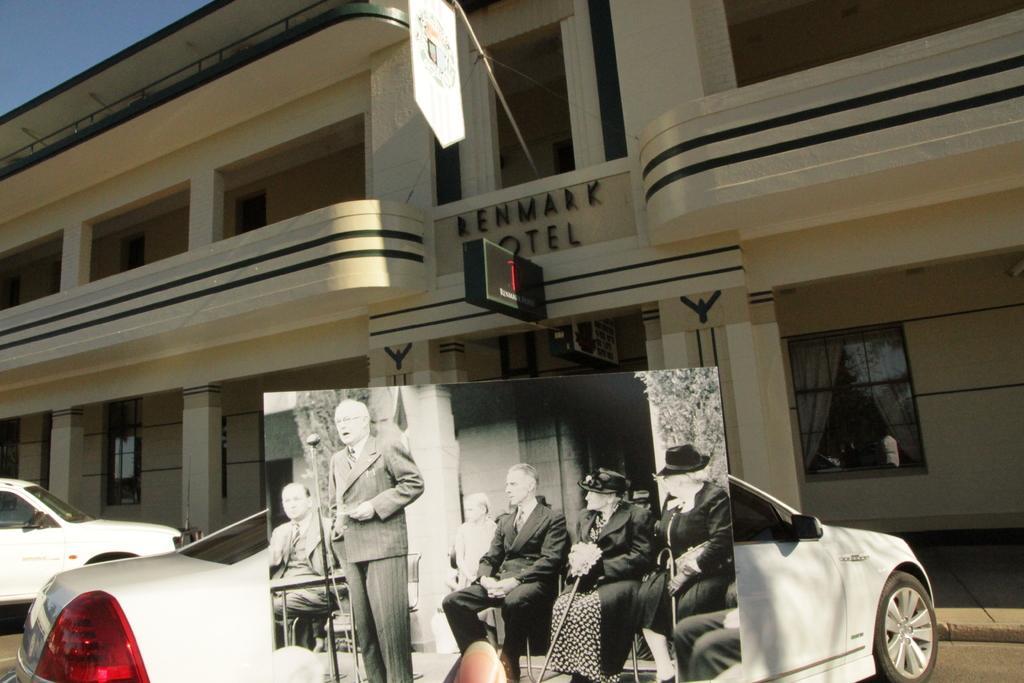Could you give a brief overview of what you see in this image? In this image we can see vehicles and building with pillars and windows. On the building there is a name. Also there are boards. In the background there is a sky. Also there is a black and white photo at the bottom is held by a person's finger. In this photo there are few people sitting and some are wearing specs. One person is standing. In front of him there is a mic with mic stand. 